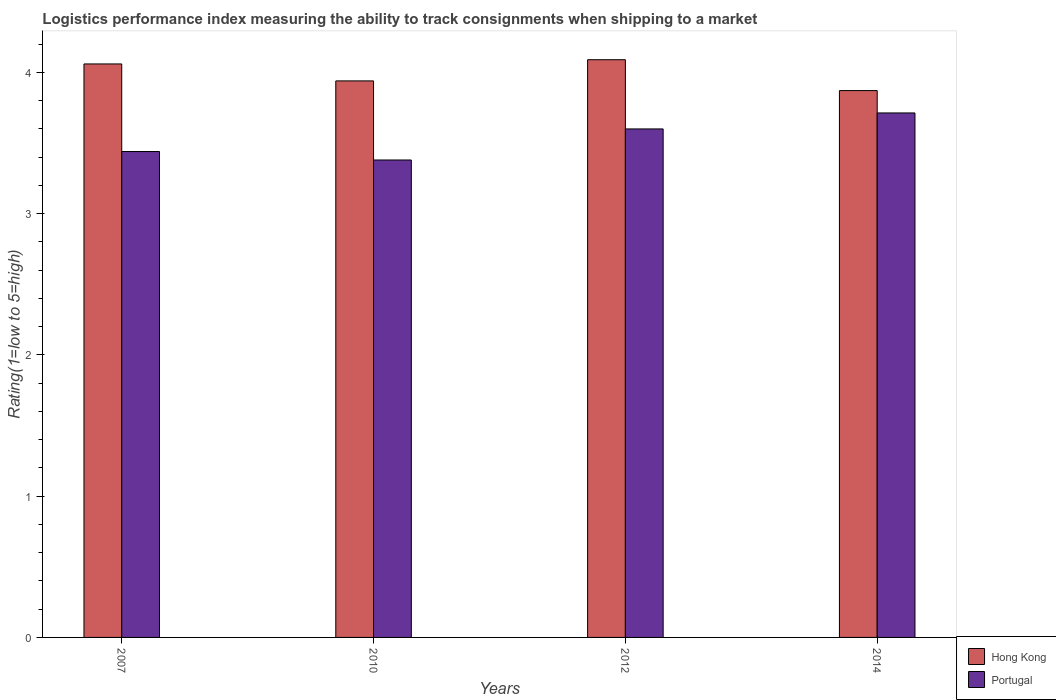How many different coloured bars are there?
Offer a terse response. 2. How many bars are there on the 1st tick from the left?
Give a very brief answer. 2. How many bars are there on the 4th tick from the right?
Keep it short and to the point. 2. What is the label of the 2nd group of bars from the left?
Give a very brief answer. 2010. What is the Logistic performance index in Portugal in 2007?
Offer a very short reply. 3.44. Across all years, what is the maximum Logistic performance index in Portugal?
Ensure brevity in your answer.  3.71. Across all years, what is the minimum Logistic performance index in Portugal?
Your response must be concise. 3.38. What is the total Logistic performance index in Hong Kong in the graph?
Make the answer very short. 15.96. What is the difference between the Logistic performance index in Hong Kong in 2007 and that in 2010?
Offer a very short reply. 0.12. What is the difference between the Logistic performance index in Hong Kong in 2007 and the Logistic performance index in Portugal in 2012?
Keep it short and to the point. 0.46. What is the average Logistic performance index in Portugal per year?
Your answer should be compact. 3.53. In the year 2007, what is the difference between the Logistic performance index in Portugal and Logistic performance index in Hong Kong?
Keep it short and to the point. -0.62. What is the ratio of the Logistic performance index in Portugal in 2007 to that in 2010?
Keep it short and to the point. 1.02. Is the Logistic performance index in Hong Kong in 2007 less than that in 2012?
Your answer should be very brief. Yes. What is the difference between the highest and the second highest Logistic performance index in Portugal?
Make the answer very short. 0.11. What is the difference between the highest and the lowest Logistic performance index in Portugal?
Offer a very short reply. 0.33. In how many years, is the Logistic performance index in Portugal greater than the average Logistic performance index in Portugal taken over all years?
Give a very brief answer. 2. What does the 2nd bar from the left in 2007 represents?
Your response must be concise. Portugal. What does the 1st bar from the right in 2014 represents?
Your answer should be compact. Portugal. How many bars are there?
Offer a very short reply. 8. How many years are there in the graph?
Offer a terse response. 4. Are the values on the major ticks of Y-axis written in scientific E-notation?
Offer a very short reply. No. Does the graph contain grids?
Offer a terse response. No. How are the legend labels stacked?
Your answer should be very brief. Vertical. What is the title of the graph?
Provide a succinct answer. Logistics performance index measuring the ability to track consignments when shipping to a market. Does "Seychelles" appear as one of the legend labels in the graph?
Ensure brevity in your answer.  No. What is the label or title of the Y-axis?
Give a very brief answer. Rating(1=low to 5=high). What is the Rating(1=low to 5=high) of Hong Kong in 2007?
Your answer should be compact. 4.06. What is the Rating(1=low to 5=high) in Portugal in 2007?
Provide a short and direct response. 3.44. What is the Rating(1=low to 5=high) of Hong Kong in 2010?
Give a very brief answer. 3.94. What is the Rating(1=low to 5=high) of Portugal in 2010?
Ensure brevity in your answer.  3.38. What is the Rating(1=low to 5=high) of Hong Kong in 2012?
Provide a short and direct response. 4.09. What is the Rating(1=low to 5=high) of Portugal in 2012?
Ensure brevity in your answer.  3.6. What is the Rating(1=low to 5=high) in Hong Kong in 2014?
Make the answer very short. 3.87. What is the Rating(1=low to 5=high) in Portugal in 2014?
Make the answer very short. 3.71. Across all years, what is the maximum Rating(1=low to 5=high) in Hong Kong?
Provide a short and direct response. 4.09. Across all years, what is the maximum Rating(1=low to 5=high) of Portugal?
Ensure brevity in your answer.  3.71. Across all years, what is the minimum Rating(1=low to 5=high) of Hong Kong?
Offer a very short reply. 3.87. Across all years, what is the minimum Rating(1=low to 5=high) in Portugal?
Keep it short and to the point. 3.38. What is the total Rating(1=low to 5=high) of Hong Kong in the graph?
Your answer should be very brief. 15.96. What is the total Rating(1=low to 5=high) of Portugal in the graph?
Give a very brief answer. 14.13. What is the difference between the Rating(1=low to 5=high) in Hong Kong in 2007 and that in 2010?
Your answer should be compact. 0.12. What is the difference between the Rating(1=low to 5=high) of Portugal in 2007 and that in 2010?
Your response must be concise. 0.06. What is the difference between the Rating(1=low to 5=high) of Hong Kong in 2007 and that in 2012?
Provide a short and direct response. -0.03. What is the difference between the Rating(1=low to 5=high) in Portugal in 2007 and that in 2012?
Give a very brief answer. -0.16. What is the difference between the Rating(1=low to 5=high) of Hong Kong in 2007 and that in 2014?
Ensure brevity in your answer.  0.19. What is the difference between the Rating(1=low to 5=high) in Portugal in 2007 and that in 2014?
Your response must be concise. -0.27. What is the difference between the Rating(1=low to 5=high) in Portugal in 2010 and that in 2012?
Make the answer very short. -0.22. What is the difference between the Rating(1=low to 5=high) of Hong Kong in 2010 and that in 2014?
Ensure brevity in your answer.  0.07. What is the difference between the Rating(1=low to 5=high) of Portugal in 2010 and that in 2014?
Give a very brief answer. -0.33. What is the difference between the Rating(1=low to 5=high) of Hong Kong in 2012 and that in 2014?
Your answer should be very brief. 0.22. What is the difference between the Rating(1=low to 5=high) of Portugal in 2012 and that in 2014?
Give a very brief answer. -0.11. What is the difference between the Rating(1=low to 5=high) in Hong Kong in 2007 and the Rating(1=low to 5=high) in Portugal in 2010?
Make the answer very short. 0.68. What is the difference between the Rating(1=low to 5=high) of Hong Kong in 2007 and the Rating(1=low to 5=high) of Portugal in 2012?
Offer a terse response. 0.46. What is the difference between the Rating(1=low to 5=high) in Hong Kong in 2007 and the Rating(1=low to 5=high) in Portugal in 2014?
Give a very brief answer. 0.35. What is the difference between the Rating(1=low to 5=high) in Hong Kong in 2010 and the Rating(1=low to 5=high) in Portugal in 2012?
Your response must be concise. 0.34. What is the difference between the Rating(1=low to 5=high) in Hong Kong in 2010 and the Rating(1=low to 5=high) in Portugal in 2014?
Offer a terse response. 0.23. What is the difference between the Rating(1=low to 5=high) of Hong Kong in 2012 and the Rating(1=low to 5=high) of Portugal in 2014?
Give a very brief answer. 0.38. What is the average Rating(1=low to 5=high) in Hong Kong per year?
Keep it short and to the point. 3.99. What is the average Rating(1=low to 5=high) in Portugal per year?
Your answer should be very brief. 3.53. In the year 2007, what is the difference between the Rating(1=low to 5=high) in Hong Kong and Rating(1=low to 5=high) in Portugal?
Give a very brief answer. 0.62. In the year 2010, what is the difference between the Rating(1=low to 5=high) in Hong Kong and Rating(1=low to 5=high) in Portugal?
Your response must be concise. 0.56. In the year 2012, what is the difference between the Rating(1=low to 5=high) of Hong Kong and Rating(1=low to 5=high) of Portugal?
Your answer should be compact. 0.49. In the year 2014, what is the difference between the Rating(1=low to 5=high) of Hong Kong and Rating(1=low to 5=high) of Portugal?
Give a very brief answer. 0.16. What is the ratio of the Rating(1=low to 5=high) in Hong Kong in 2007 to that in 2010?
Offer a terse response. 1.03. What is the ratio of the Rating(1=low to 5=high) of Portugal in 2007 to that in 2010?
Offer a terse response. 1.02. What is the ratio of the Rating(1=low to 5=high) in Hong Kong in 2007 to that in 2012?
Your answer should be compact. 0.99. What is the ratio of the Rating(1=low to 5=high) in Portugal in 2007 to that in 2012?
Keep it short and to the point. 0.96. What is the ratio of the Rating(1=low to 5=high) of Hong Kong in 2007 to that in 2014?
Ensure brevity in your answer.  1.05. What is the ratio of the Rating(1=low to 5=high) in Portugal in 2007 to that in 2014?
Provide a short and direct response. 0.93. What is the ratio of the Rating(1=low to 5=high) in Hong Kong in 2010 to that in 2012?
Give a very brief answer. 0.96. What is the ratio of the Rating(1=low to 5=high) of Portugal in 2010 to that in 2012?
Provide a succinct answer. 0.94. What is the ratio of the Rating(1=low to 5=high) in Hong Kong in 2010 to that in 2014?
Provide a short and direct response. 1.02. What is the ratio of the Rating(1=low to 5=high) of Portugal in 2010 to that in 2014?
Provide a short and direct response. 0.91. What is the ratio of the Rating(1=low to 5=high) in Hong Kong in 2012 to that in 2014?
Provide a short and direct response. 1.06. What is the ratio of the Rating(1=low to 5=high) in Portugal in 2012 to that in 2014?
Your response must be concise. 0.97. What is the difference between the highest and the second highest Rating(1=low to 5=high) in Portugal?
Provide a short and direct response. 0.11. What is the difference between the highest and the lowest Rating(1=low to 5=high) of Hong Kong?
Offer a very short reply. 0.22. What is the difference between the highest and the lowest Rating(1=low to 5=high) in Portugal?
Offer a very short reply. 0.33. 